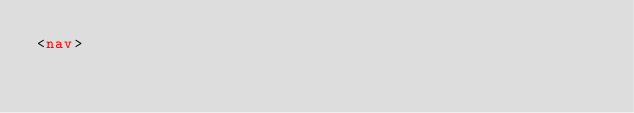<code> <loc_0><loc_0><loc_500><loc_500><_HTML_><nav></code> 